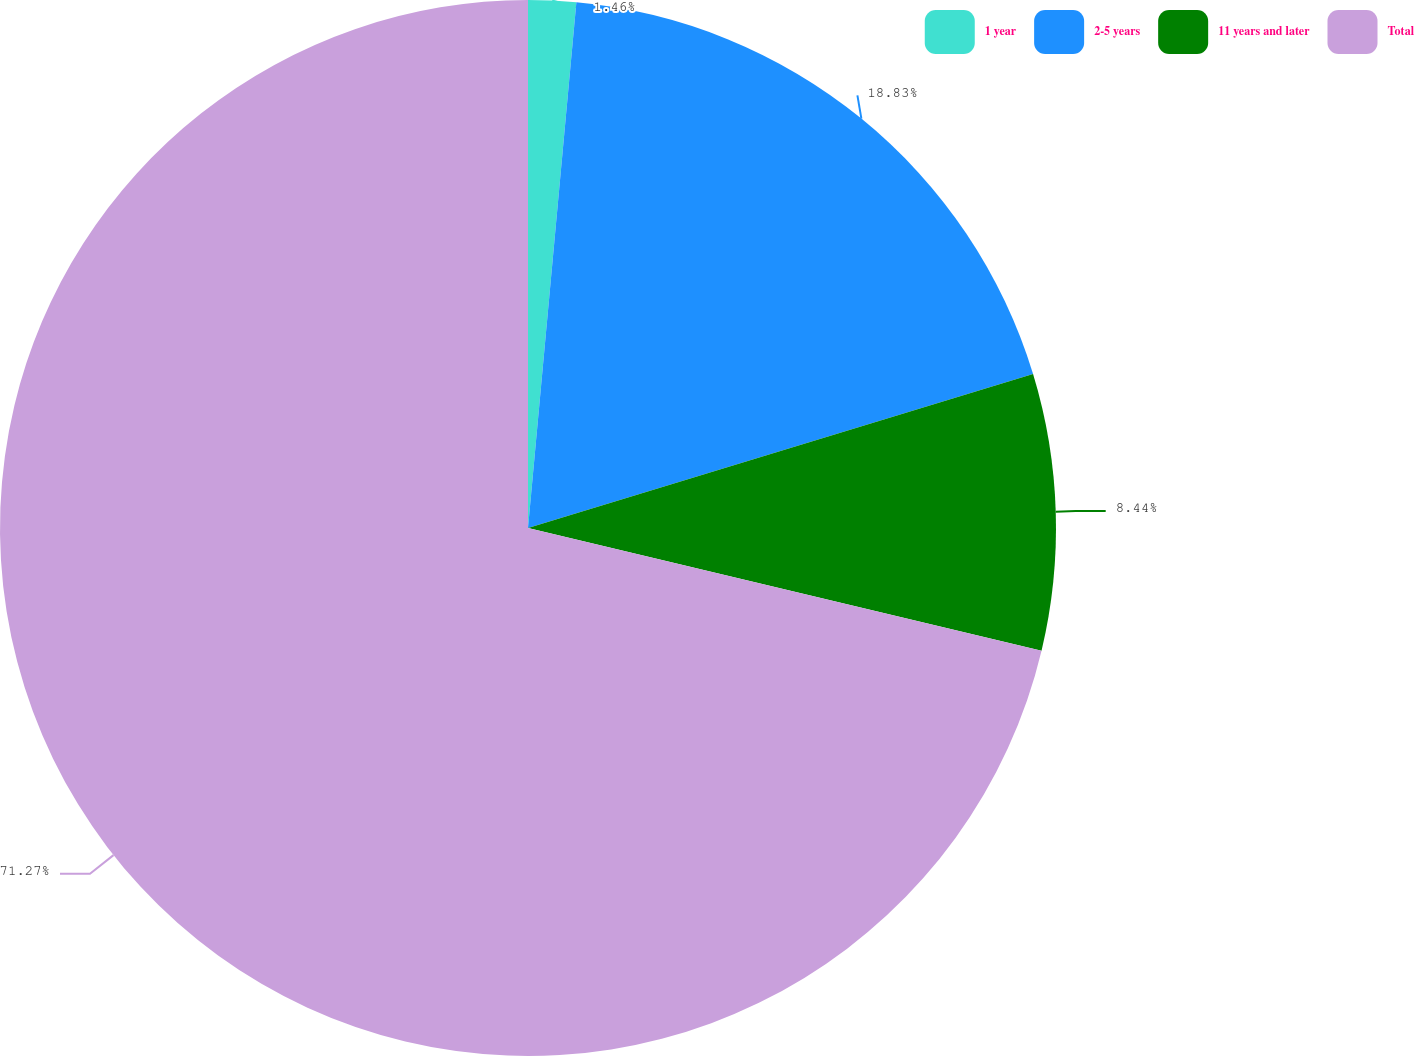<chart> <loc_0><loc_0><loc_500><loc_500><pie_chart><fcel>1 year<fcel>2-5 years<fcel>11 years and later<fcel>Total<nl><fcel>1.46%<fcel>18.83%<fcel>8.44%<fcel>71.26%<nl></chart> 